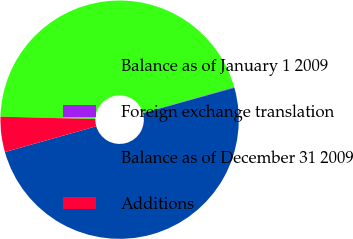Convert chart. <chart><loc_0><loc_0><loc_500><loc_500><pie_chart><fcel>Balance as of January 1 2009<fcel>Foreign exchange translation<fcel>Balance as of December 31 2009<fcel>Additions<nl><fcel>45.22%<fcel>0.06%<fcel>49.94%<fcel>4.78%<nl></chart> 